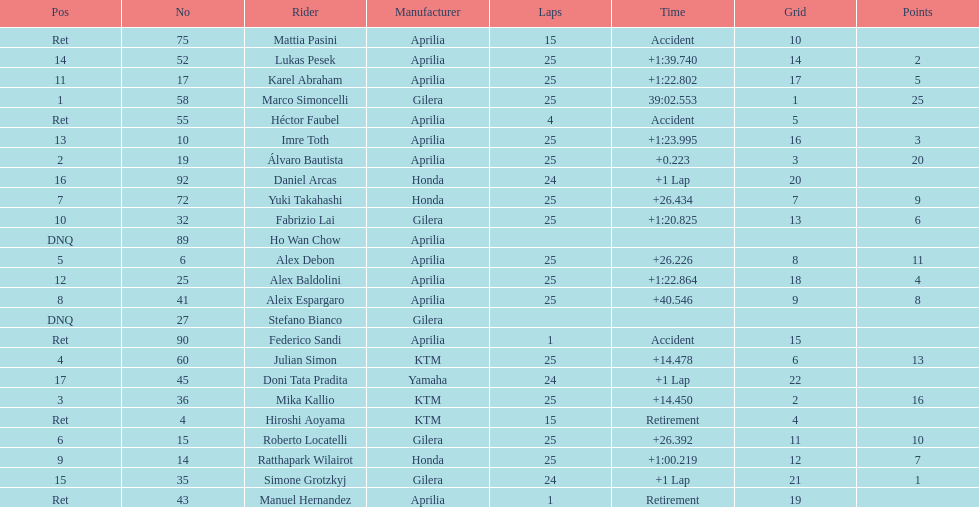What is the total number of laps performed by rider imre toth? 25. 